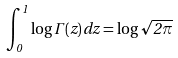<formula> <loc_0><loc_0><loc_500><loc_500>\int _ { 0 } ^ { 1 } \log \Gamma ( z ) \, d z = \log \sqrt { 2 \pi }</formula> 